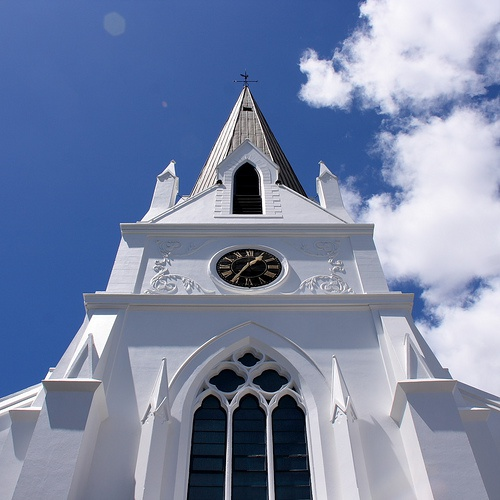Describe the objects in this image and their specific colors. I can see a clock in gray, black, and darkgray tones in this image. 